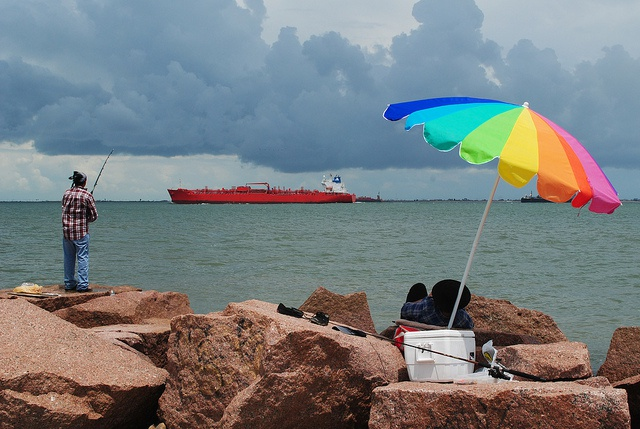Describe the objects in this image and their specific colors. I can see umbrella in darkgray, turquoise, orange, khaki, and lightgreen tones, boat in darkgray, brown, maroon, and black tones, people in darkgray, black, gray, and navy tones, people in darkgray, black, gray, and darkblue tones, and boat in darkgray, gray, and black tones in this image. 